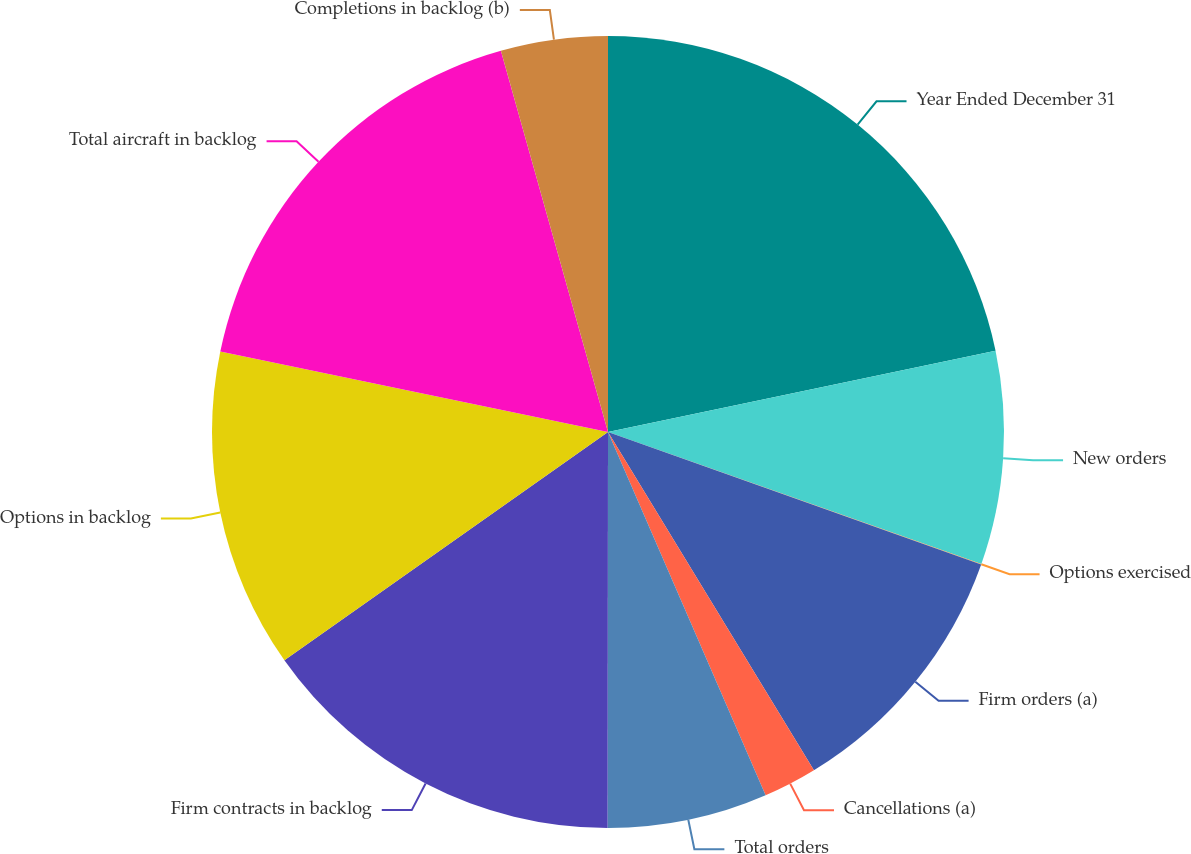Convert chart. <chart><loc_0><loc_0><loc_500><loc_500><pie_chart><fcel>Year Ended December 31<fcel>New orders<fcel>Options exercised<fcel>Firm orders (a)<fcel>Cancellations (a)<fcel>Total orders<fcel>Firm contracts in backlog<fcel>Options in backlog<fcel>Total aircraft in backlog<fcel>Completions in backlog (b)<nl><fcel>21.71%<fcel>8.7%<fcel>0.02%<fcel>10.87%<fcel>2.19%<fcel>6.53%<fcel>15.21%<fcel>13.04%<fcel>17.38%<fcel>4.36%<nl></chart> 